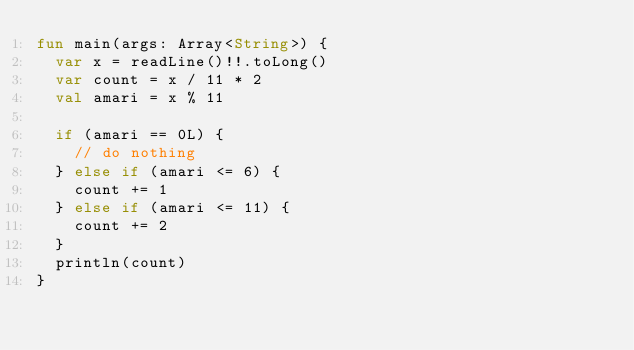Convert code to text. <code><loc_0><loc_0><loc_500><loc_500><_Kotlin_>fun main(args: Array<String>) {
  var x = readLine()!!.toLong()
  var count = x / 11 * 2
  val amari = x % 11

  if (amari == 0L) {
    // do nothing
  } else if (amari <= 6) {
    count += 1
  } else if (amari <= 11) {
    count += 2
  }
  println(count)
}</code> 